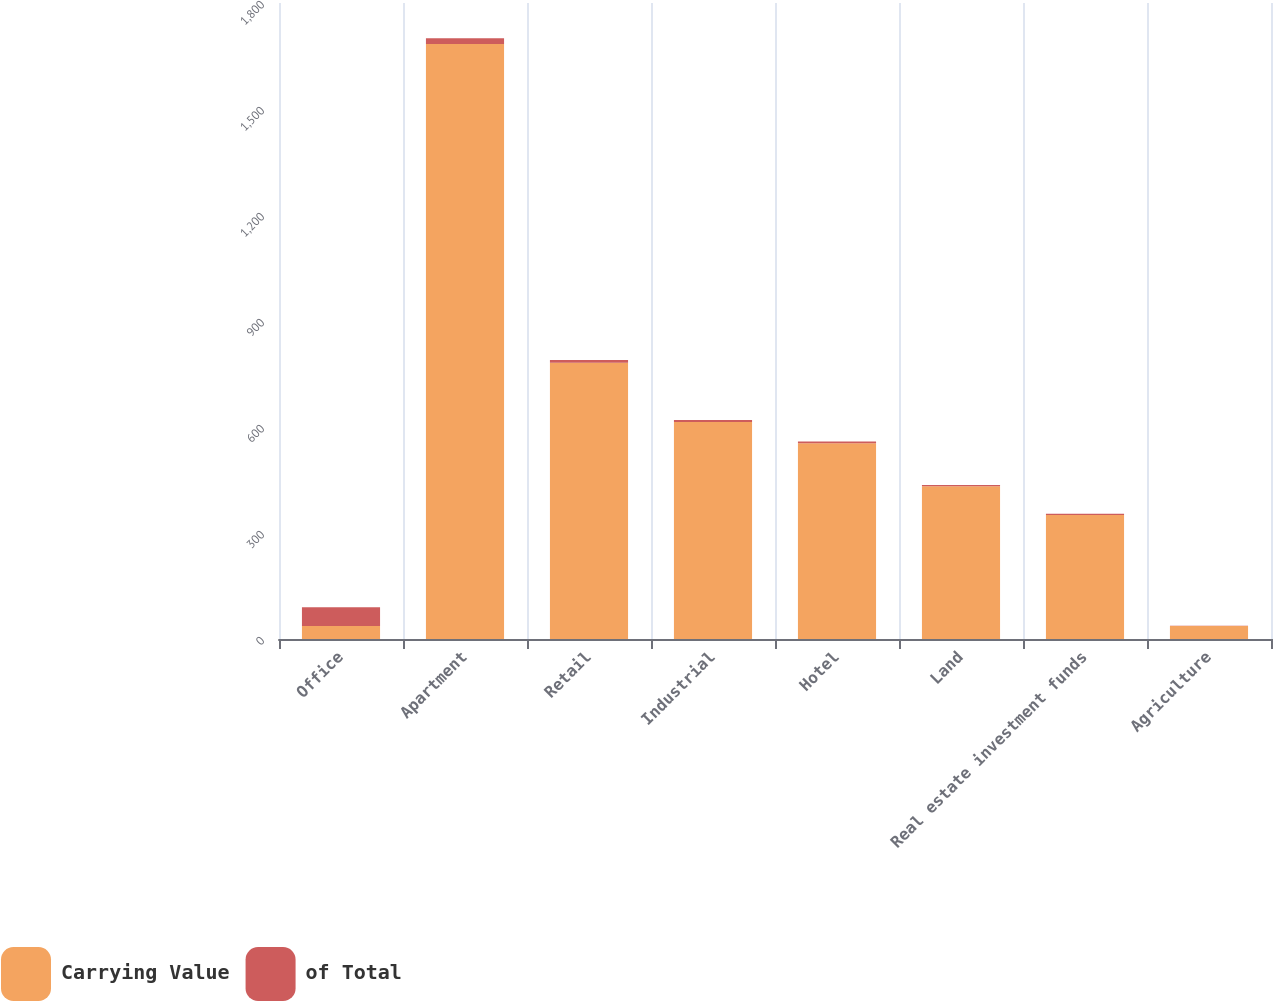Convert chart. <chart><loc_0><loc_0><loc_500><loc_500><stacked_bar_chart><ecel><fcel>Office<fcel>Apartment<fcel>Retail<fcel>Industrial<fcel>Hotel<fcel>Land<fcel>Real estate investment funds<fcel>Agriculture<nl><fcel>Carrying Value<fcel>37<fcel>1684<fcel>782<fcel>614<fcel>554<fcel>432<fcel>351<fcel>37<nl><fcel>of Total<fcel>53<fcel>16<fcel>7.4<fcel>5.8<fcel>5.3<fcel>4.1<fcel>3.3<fcel>0.4<nl></chart> 